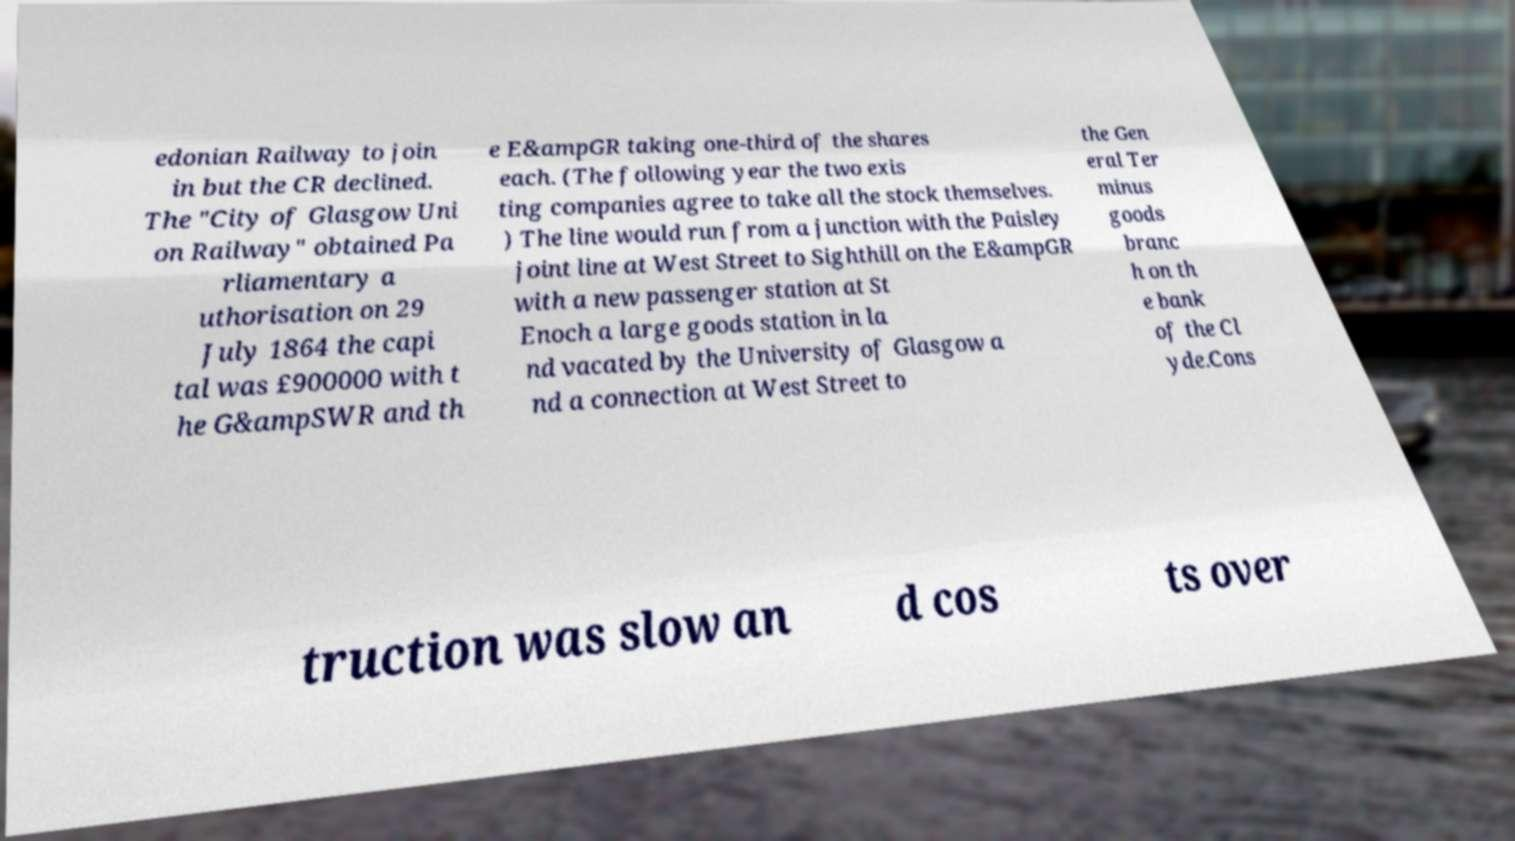Could you assist in decoding the text presented in this image and type it out clearly? edonian Railway to join in but the CR declined. The "City of Glasgow Uni on Railway" obtained Pa rliamentary a uthorisation on 29 July 1864 the capi tal was £900000 with t he G&ampSWR and th e E&ampGR taking one-third of the shares each. (The following year the two exis ting companies agree to take all the stock themselves. ) The line would run from a junction with the Paisley joint line at West Street to Sighthill on the E&ampGR with a new passenger station at St Enoch a large goods station in la nd vacated by the University of Glasgow a nd a connection at West Street to the Gen eral Ter minus goods branc h on th e bank of the Cl yde.Cons truction was slow an d cos ts over 